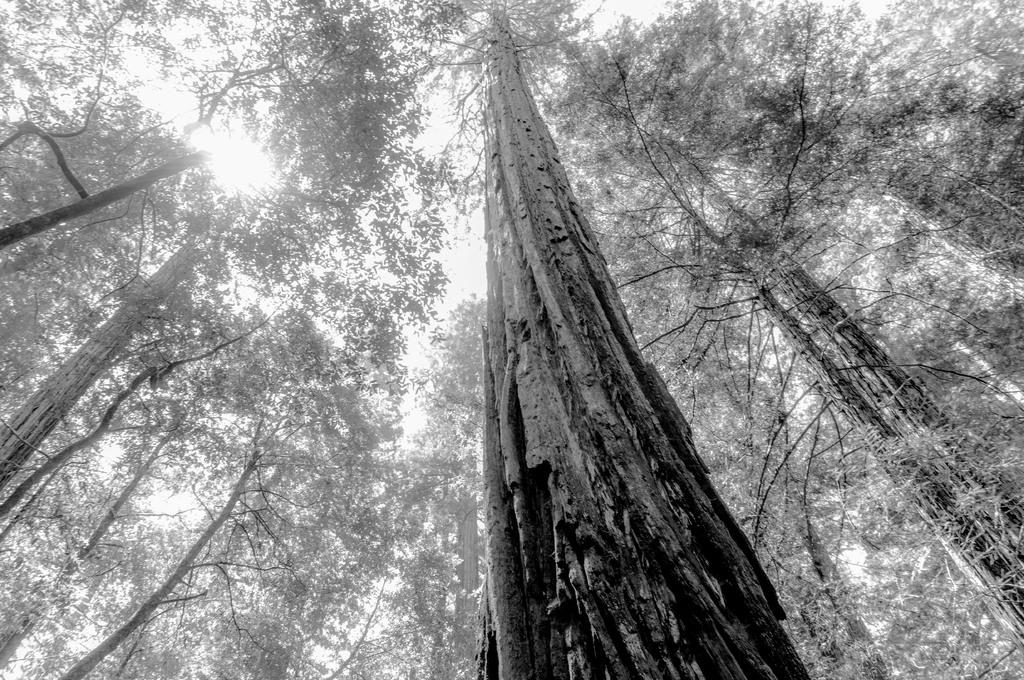What is the color scheme of the image? The image is black and white. From what perspective was the image taken? The image was taken from a low angle. What can be seen in the background of the image? There are trees and the sky visible in the background. What type of advertisement can be seen in the image? There is no advertisement present in the image. What is the quiver used for in the image? There is no quiver present in the image. 